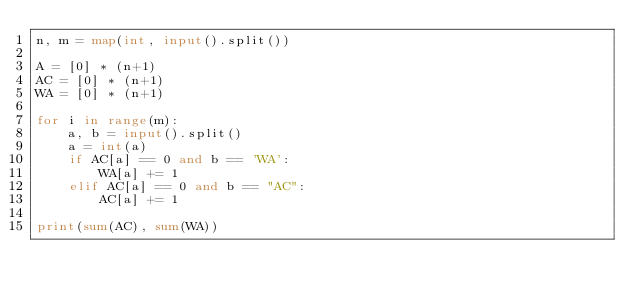Convert code to text. <code><loc_0><loc_0><loc_500><loc_500><_Python_>n, m = map(int, input().split())

A = [0] * (n+1)
AC = [0] * (n+1)
WA = [0] * (n+1)

for i in range(m):
    a, b = input().split()
    a = int(a)
    if AC[a] == 0 and b == 'WA':
        WA[a] += 1
    elif AC[a] == 0 and b == "AC":
        AC[a] += 1

print(sum(AC), sum(WA))</code> 